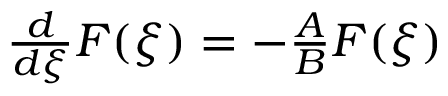<formula> <loc_0><loc_0><loc_500><loc_500>\begin{array} { r } { \frac { d } { d \xi } F ( \xi ) = - \frac { A } { B } F ( \xi ) } \end{array}</formula> 